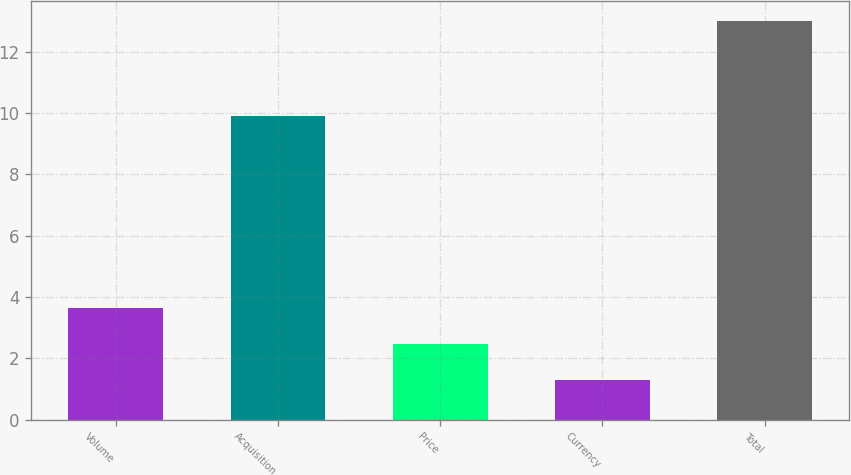<chart> <loc_0><loc_0><loc_500><loc_500><bar_chart><fcel>Volume<fcel>Acquisition<fcel>Price<fcel>Currency<fcel>Total<nl><fcel>3.64<fcel>9.9<fcel>2.47<fcel>1.3<fcel>13<nl></chart> 